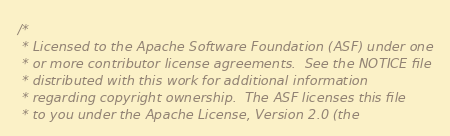<code> <loc_0><loc_0><loc_500><loc_500><_C++_>/*
 * Licensed to the Apache Software Foundation (ASF) under one
 * or more contributor license agreements.  See the NOTICE file
 * distributed with this work for additional information
 * regarding copyright ownership.  The ASF licenses this file
 * to you under the Apache License, Version 2.0 (the</code> 